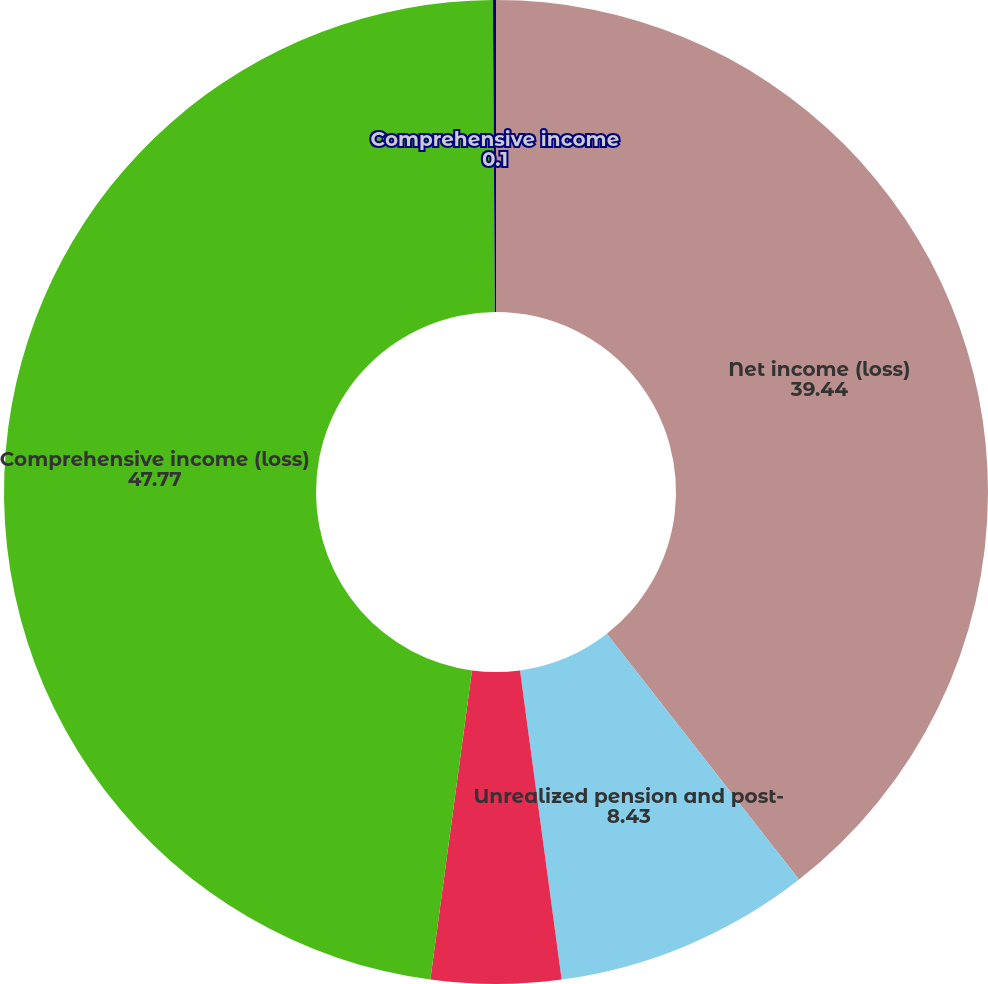Convert chart. <chart><loc_0><loc_0><loc_500><loc_500><pie_chart><fcel>Net income (loss)<fcel>Unrealized pension and post-<fcel>Reclassification for pension<fcel>Comprehensive income (loss)<fcel>Comprehensive income<nl><fcel>39.44%<fcel>8.43%<fcel>4.26%<fcel>47.77%<fcel>0.1%<nl></chart> 